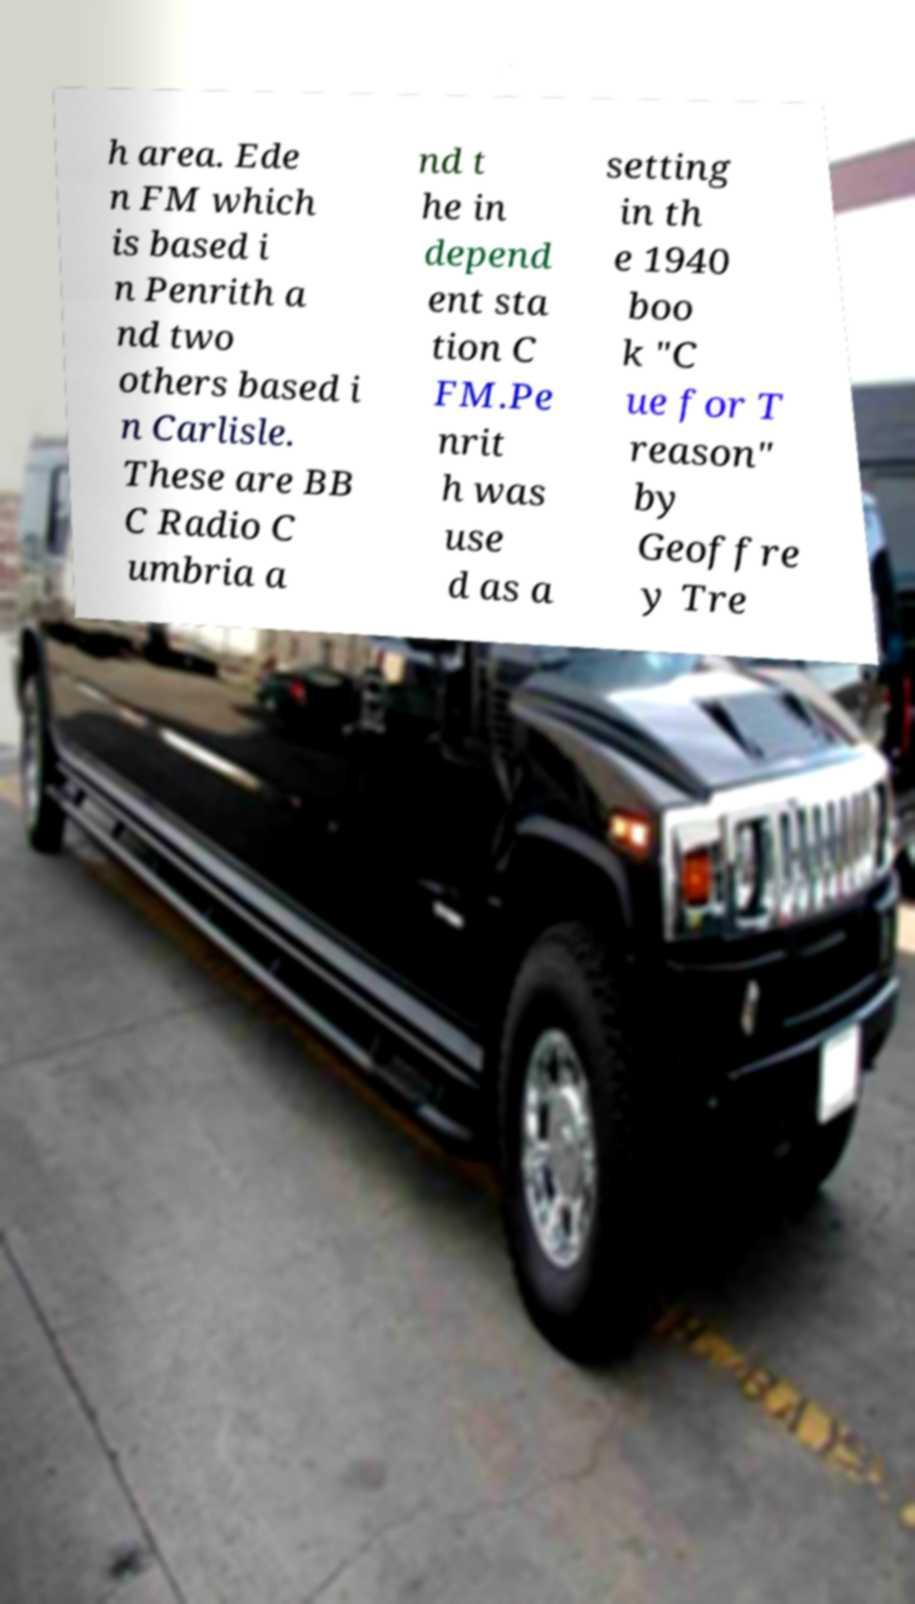I need the written content from this picture converted into text. Can you do that? h area. Ede n FM which is based i n Penrith a nd two others based i n Carlisle. These are BB C Radio C umbria a nd t he in depend ent sta tion C FM.Pe nrit h was use d as a setting in th e 1940 boo k "C ue for T reason" by Geoffre y Tre 